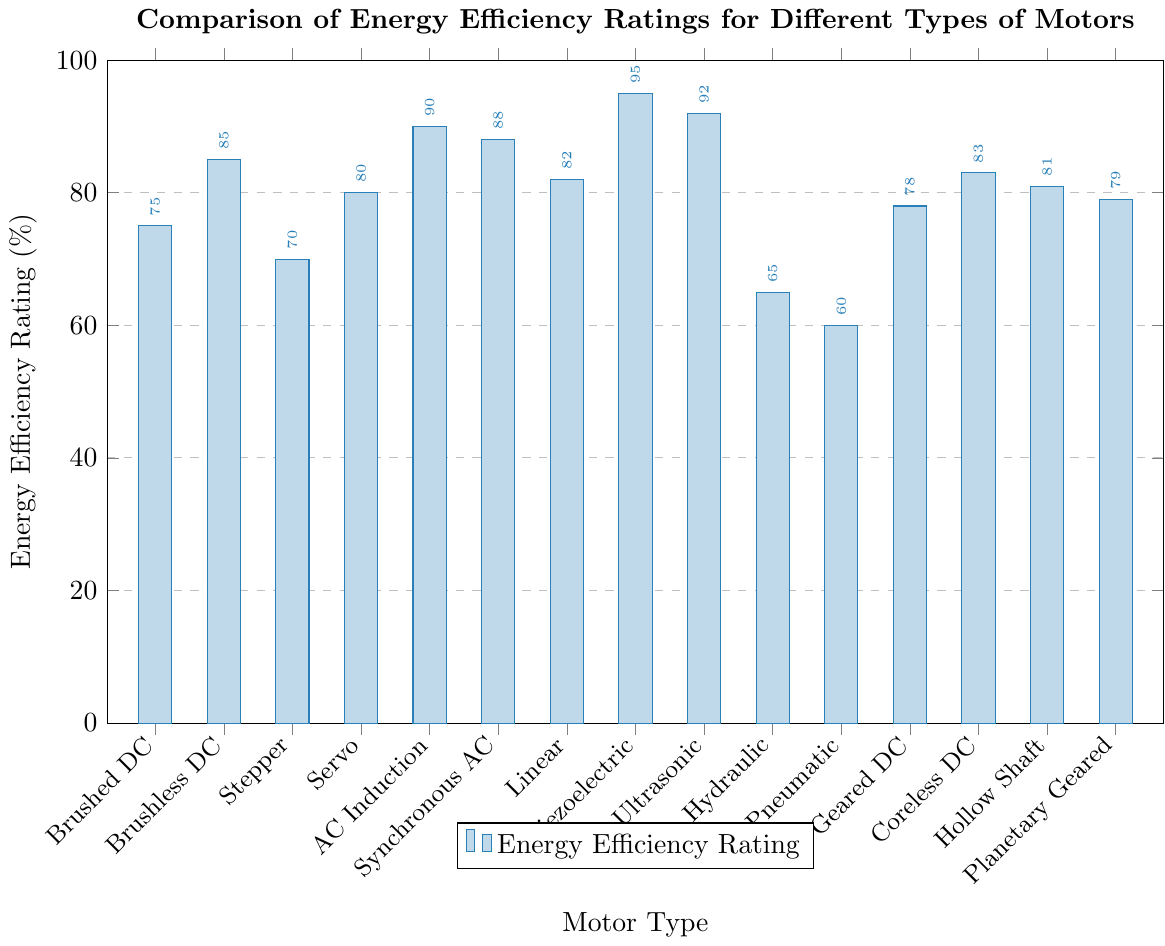Which motor type has the highest energy efficiency rating? By examining the height of the bars in the chart, we look for the tallest bar which corresponds to the highest energy efficiency rating. The bar for Piezoelectric motor is the highest.
Answer: Piezoelectric Which motor type has the lowest energy efficiency rating? By examining the height of the bars in the chart, we look for the shortest bar which indicates the lowest energy efficiency rating. The bar for Pneumatic motor is the shortest.
Answer: Pneumatic Compare the energy efficiency ratings of Brushed DC and Brushless DC motors. Which one is higher? We compare the bars for Brushed DC and Brushless DC motors. The Brushless DC motor's bar is taller than the Brushed DC motor's bar.
Answer: Brushless DC What's the difference in energy efficiency rating between the Ultrasonic and Hydraulic motors? The energy efficiency ratings for Ultrasonic and Hydraulic motors are 92% and 65% respectively. The difference is calculated as 92 - 65.
Answer: 27 If we average the energy efficiency ratings of Servo, AC Induction, and Synchronous AC motors, what value do we get? We sum the energy efficiency ratings of Servo (80%), AC Induction (90%), and Synchronous AC (88%) motors, then divide by 3 to find the average: (80 + 90 + 88) / 3.
Answer: 86 How much more efficient is the Piezoelectric motor compared to the Stepper motor? The energy efficiency ratings for Piezoelectric and Stepper motors are 95% and 70% respectively. The difference in their efficiency is obtained by subtracting 70 from 95.
Answer: 25 Rank the top three most energy-efficient motor types. We look for the three tallest bars in the chart. The motor types corresponding to these bars are Piezoelectric, Ultrasonic, and AC Induction.
Answer: Piezoelectric, Ultrasonic, AC Induction Which motor types have an energy efficiency rating greater than 85% but less than 90%? We identify the bars that fall between the 85% and 90% marks on the y-axis. These are Brushless DC, Synchronous AC, and Coreless DC motors.
Answer: Brushless DC, Synchronous AC, Coreless DC What is the median energy efficiency rating of all the motor types listed? To find the median, we first list all energy efficiency ratings in ascending order (60, 65, 70, 75, 78, 79, 80, 81, 82, 83, 85, 88, 90, 92, 95). The middle value is the 8th value when listed out, which is 81.
Answer: 81 